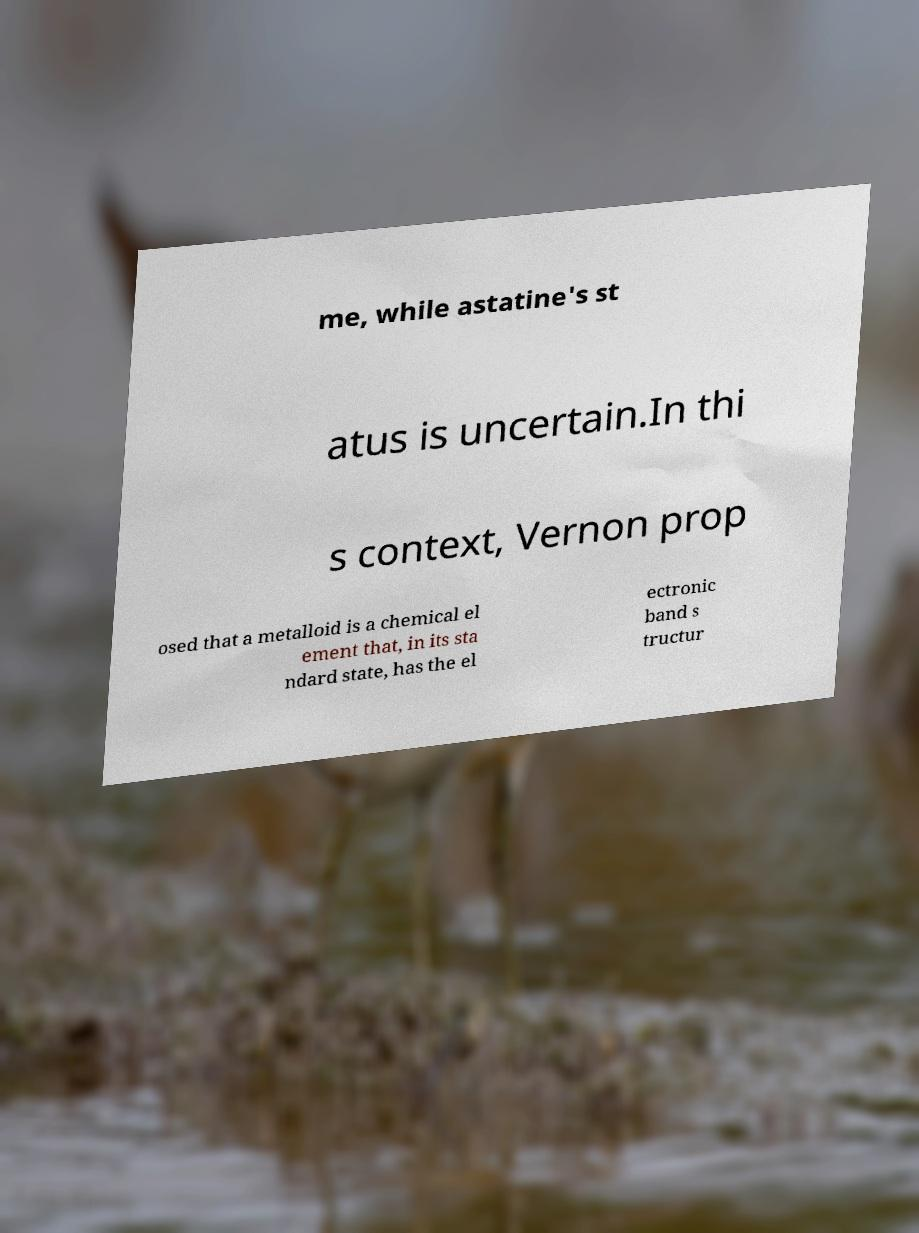Can you accurately transcribe the text from the provided image for me? me, while astatine's st atus is uncertain.In thi s context, Vernon prop osed that a metalloid is a chemical el ement that, in its sta ndard state, has the el ectronic band s tructur 